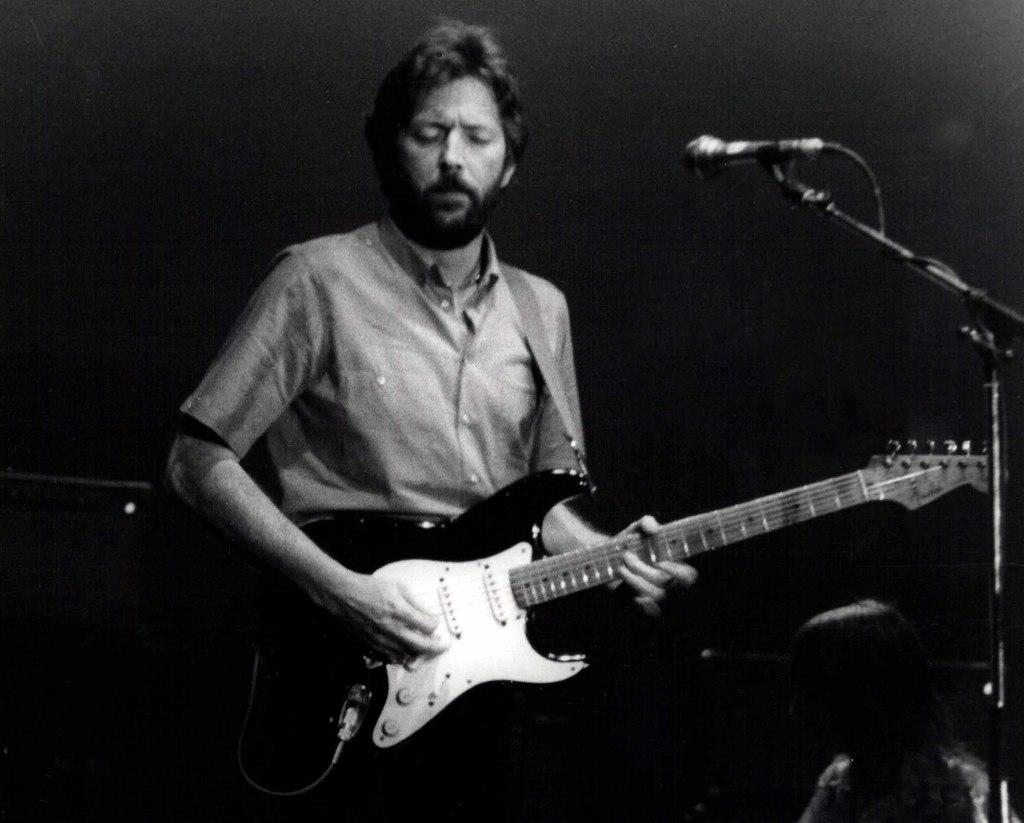What is the man in the image holding? The man is holding a guitar. What object is present in the image that is typically used for amplifying sound? There is a microphone in the image. What type of hammer is the man using to play the guitar in the image? There is no hammer present in the image, and the man is not using a hammer to play the guitar. How is the sleet affecting the distribution of sound in the image? There is no mention of sleet in the image, and therefore it cannot be affecting the distribution of sound. 